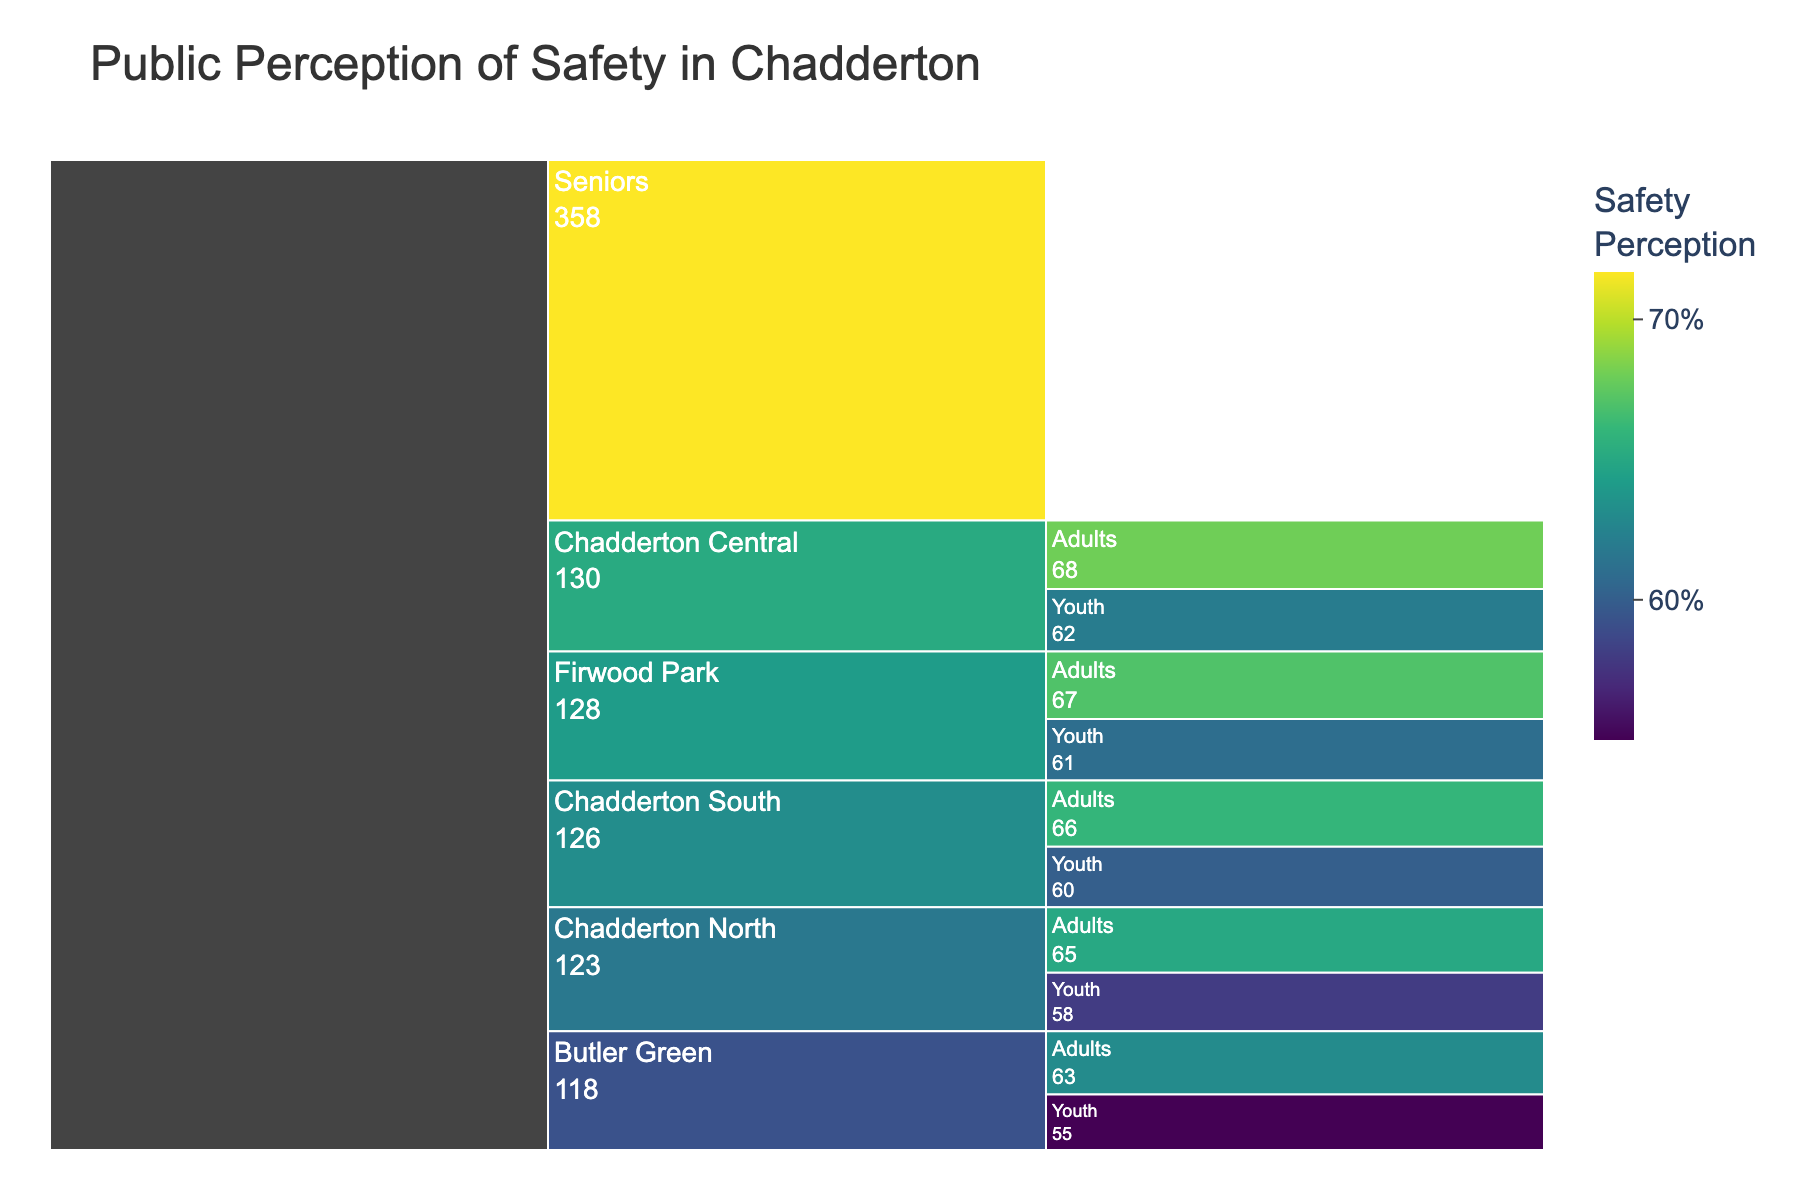What's the title of the chart? The title of the chart is usually displayed at the top of the figure. In this case, you can see the title clearly states, "Public Perception of Safety in Chadderton".
Answer: Public Perception of Safety in Chadderton What color scale is used in the chart? The colors shown in the chart range from different shades based on the 'Viridis' color scale, which typically transitions from purple to green.
Answer: Viridis How many neighborhoods are represented in the chart? You can see each main branch of the icicle chart starts with a distinct neighborhood name. Counting these main branches shows that there are five neighborhoods: Chadderton Central, Chadderton North, Chadderton South, Butler Green, and Firwood Park.
Answer: 5 Which demographic group has the highest safety perception score in Chadderton Central? Within the Chadderton Central portion of the chart, each segment represents a different demographic group. The segment with the highest value is for Seniors with a score of 75%.
Answer: Seniors Compare the safety perception of Youth in Firwood Park and Butler Green. Which one has a higher perception score? Look at the segments corresponding to Youth in Firwood Park and Youth in Butler Green. Firwood Park Youth has a safety perception score of 61%, while Butler Green Youth has a score of 55%. Firwood Park Youth has the higher score.
Answer: Firwood Park Youth What is the combined safety perception score of Adults in all neighborhoods? To find the total score for Adults across all neighborhoods, sum the score values for Adults in each: 68 (Central) + 65 (North) + 66 (South) + 63 (Butler) + 67 (Firwood) = 329.
Answer: 329 Which neighborhood has the lowest safety perception score for any demographic? Identify the lowest values in each neighborhood. Butler Green Youth has the lowest score overall with a value of 55%.
Answer: Butler Green Youth What is the difference in safety perception scores between Seniors and Youth in Chadderton South? Look at the respective values for Seniors and Youth in Chadderton South: Seniors have a score of 72%, and Youth have 60%. The difference is 72 - 60 = 12.
Answer: 12 What is the range of safety perception scores in Chadderton North? Find the maximum and minimum values for Chadderton North: Seniors have 70, and Youth have 58. The range is 70 - 58 = 12.
Answer: 12 Which neighborhood has the highest average safety perception score across all demographic groups? Calculate the average safety perception score for each neighborhood and compare. For example, for Chadderton Central: (75 + 68 + 62) / 3 = 68.3. After calculating for all neighborhoods, Chadderton Central has the highest average.
Answer: Chadderton Central 